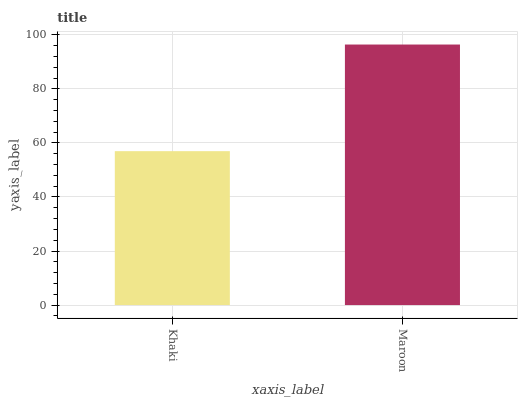Is Khaki the minimum?
Answer yes or no. Yes. Is Maroon the maximum?
Answer yes or no. Yes. Is Maroon the minimum?
Answer yes or no. No. Is Maroon greater than Khaki?
Answer yes or no. Yes. Is Khaki less than Maroon?
Answer yes or no. Yes. Is Khaki greater than Maroon?
Answer yes or no. No. Is Maroon less than Khaki?
Answer yes or no. No. Is Maroon the high median?
Answer yes or no. Yes. Is Khaki the low median?
Answer yes or no. Yes. Is Khaki the high median?
Answer yes or no. No. Is Maroon the low median?
Answer yes or no. No. 